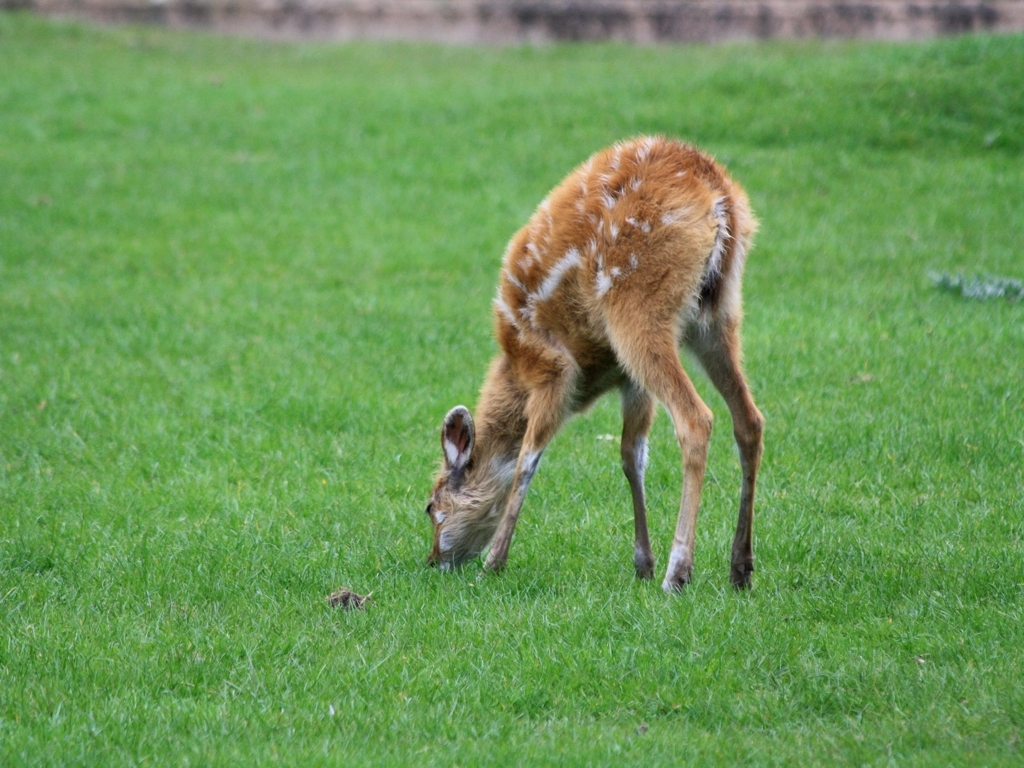Can you tell me more about the behavior depicted in this image? The fawn is grazing, which is typical behavior for deer. They often feed on grass, leaves, and sometimes even flowers or fruits depending on what's available in their habitat. 